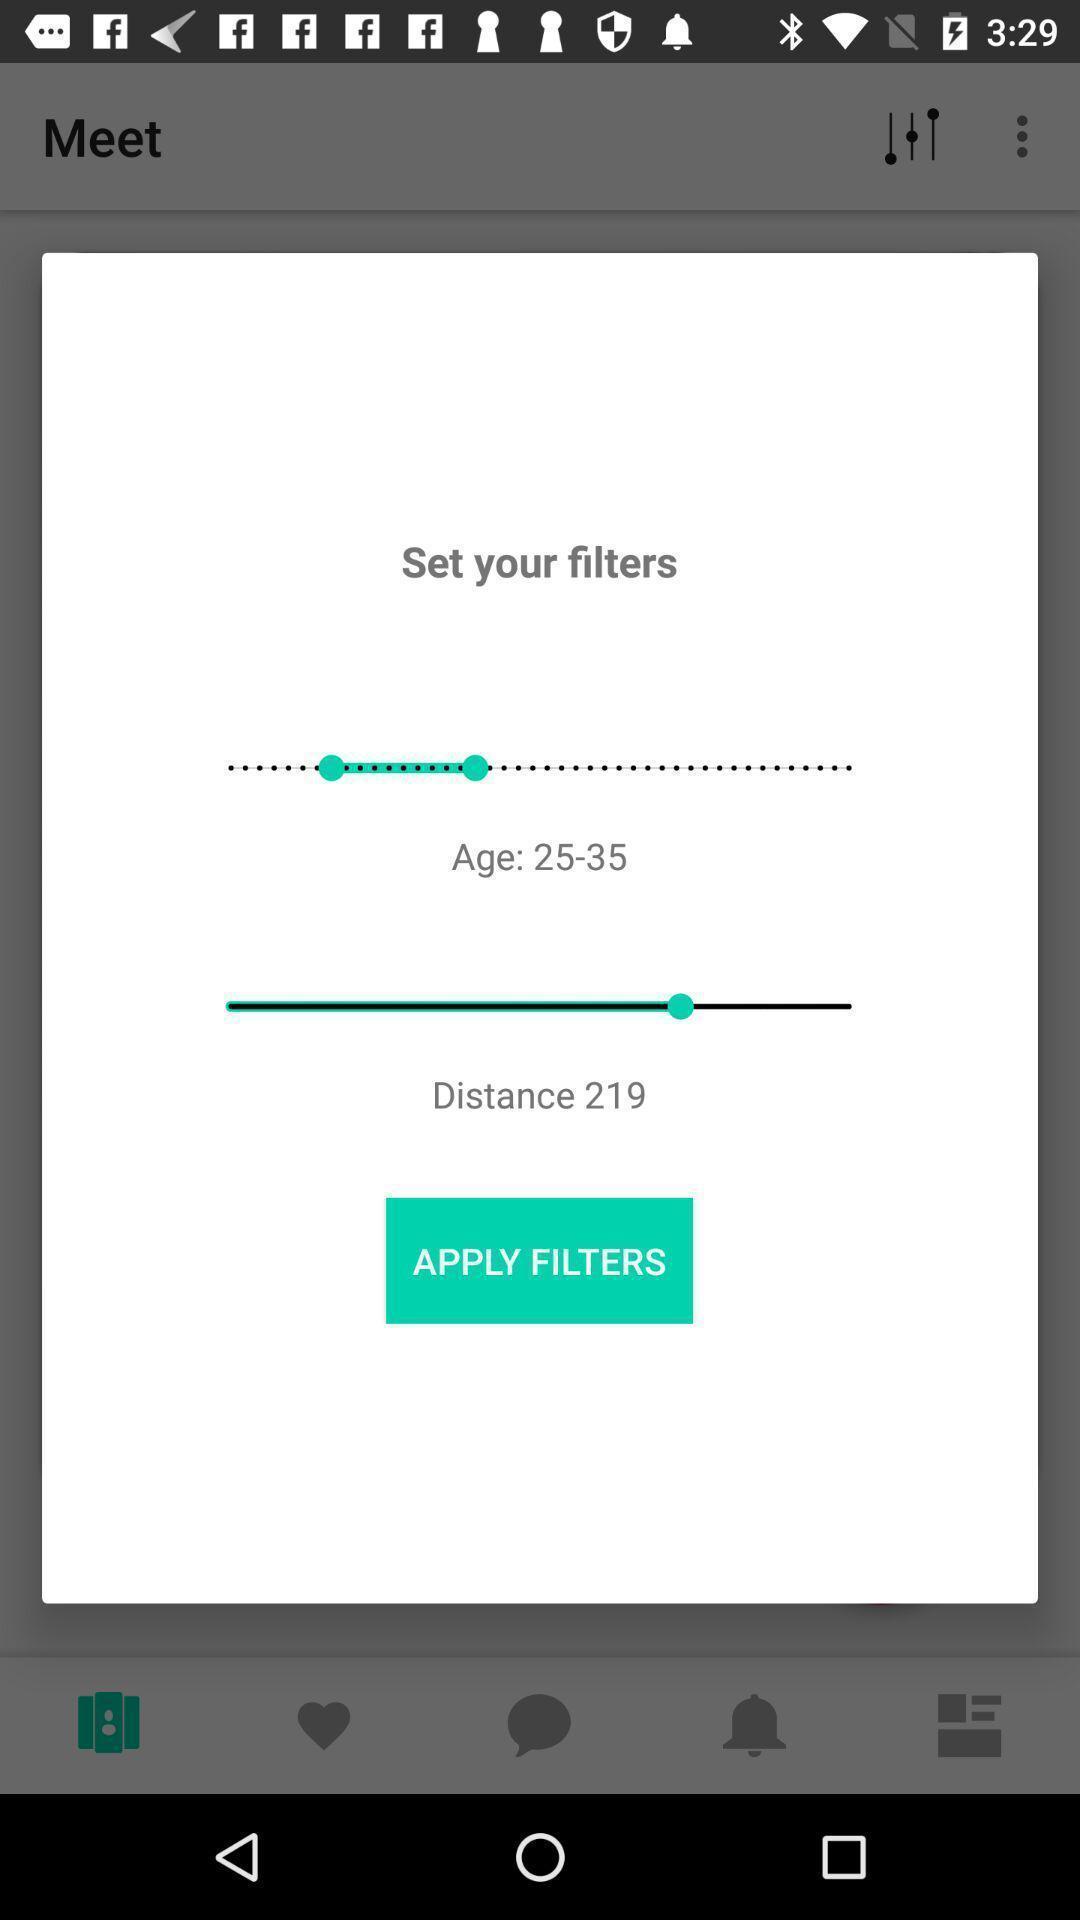Give me a narrative description of this picture. Pop up with different filters. 